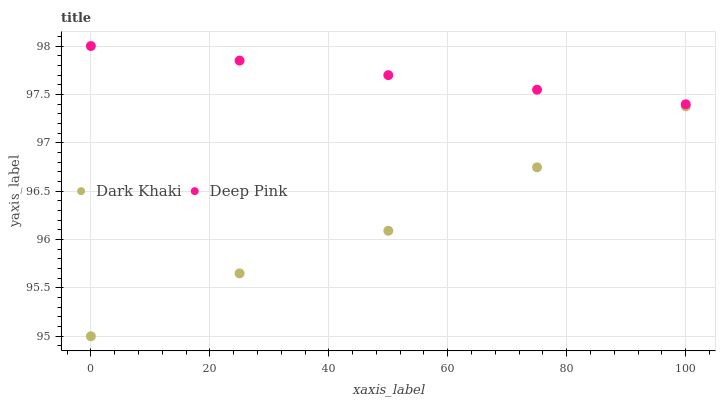Does Dark Khaki have the minimum area under the curve?
Answer yes or no. Yes. Does Deep Pink have the maximum area under the curve?
Answer yes or no. Yes. Does Deep Pink have the minimum area under the curve?
Answer yes or no. No. Is Deep Pink the smoothest?
Answer yes or no. Yes. Is Dark Khaki the roughest?
Answer yes or no. Yes. Is Deep Pink the roughest?
Answer yes or no. No. Does Dark Khaki have the lowest value?
Answer yes or no. Yes. Does Deep Pink have the lowest value?
Answer yes or no. No. Does Deep Pink have the highest value?
Answer yes or no. Yes. Is Dark Khaki less than Deep Pink?
Answer yes or no. Yes. Is Deep Pink greater than Dark Khaki?
Answer yes or no. Yes. Does Dark Khaki intersect Deep Pink?
Answer yes or no. No. 